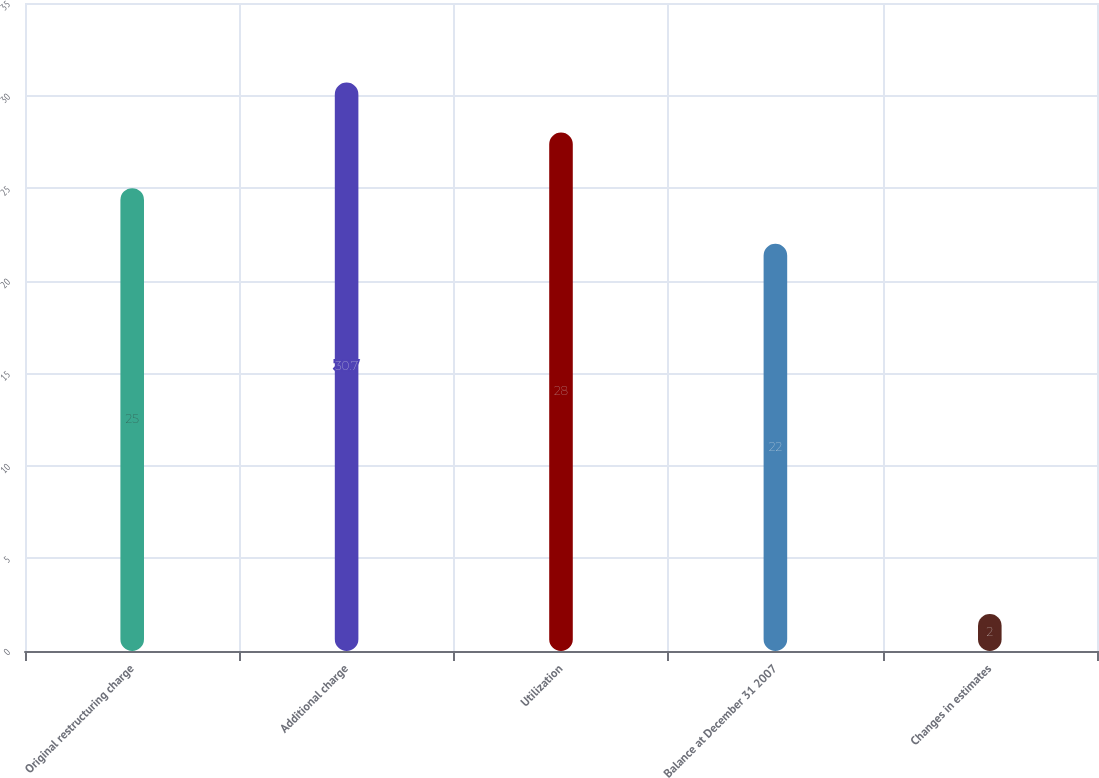Convert chart to OTSL. <chart><loc_0><loc_0><loc_500><loc_500><bar_chart><fcel>Original restructuring charge<fcel>Additional charge<fcel>Utilization<fcel>Balance at December 31 2007<fcel>Changes in estimates<nl><fcel>25<fcel>30.7<fcel>28<fcel>22<fcel>2<nl></chart> 